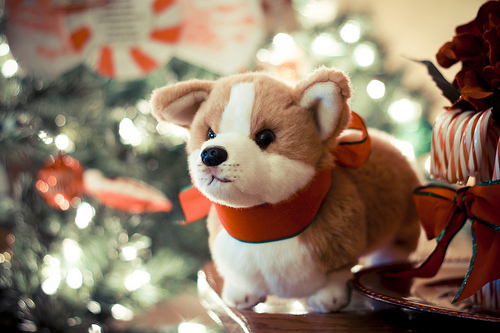<image>
Is the dog in front of the christmas tree? Yes. The dog is positioned in front of the christmas tree, appearing closer to the camera viewpoint. 